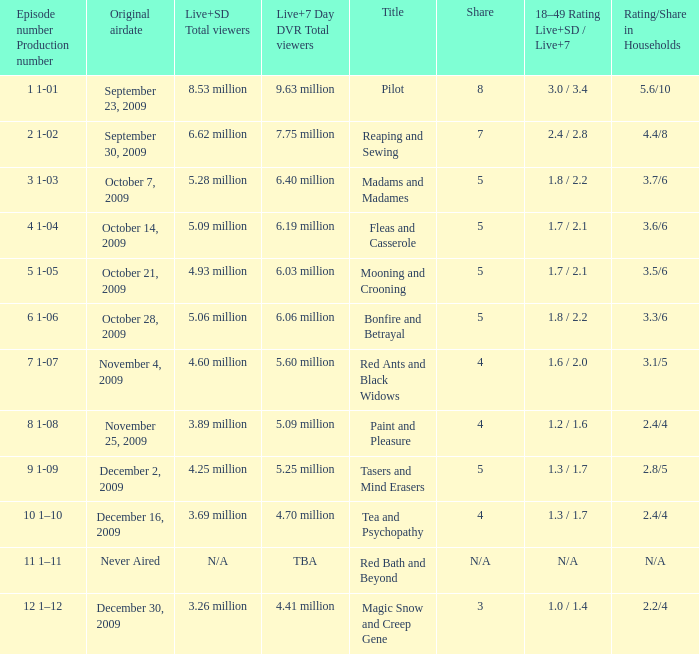When did the episode that had 5.09 million total viewers (both Live and SD types) first air? October 14, 2009. 